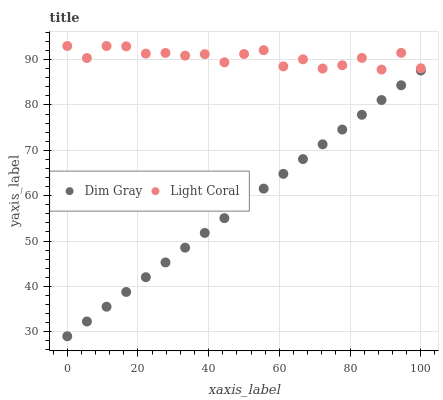Does Dim Gray have the minimum area under the curve?
Answer yes or no. Yes. Does Light Coral have the maximum area under the curve?
Answer yes or no. Yes. Does Dim Gray have the maximum area under the curve?
Answer yes or no. No. Is Dim Gray the smoothest?
Answer yes or no. Yes. Is Light Coral the roughest?
Answer yes or no. Yes. Is Dim Gray the roughest?
Answer yes or no. No. Does Dim Gray have the lowest value?
Answer yes or no. Yes. Does Light Coral have the highest value?
Answer yes or no. Yes. Does Dim Gray have the highest value?
Answer yes or no. No. Is Dim Gray less than Light Coral?
Answer yes or no. Yes. Is Light Coral greater than Dim Gray?
Answer yes or no. Yes. Does Dim Gray intersect Light Coral?
Answer yes or no. No. 